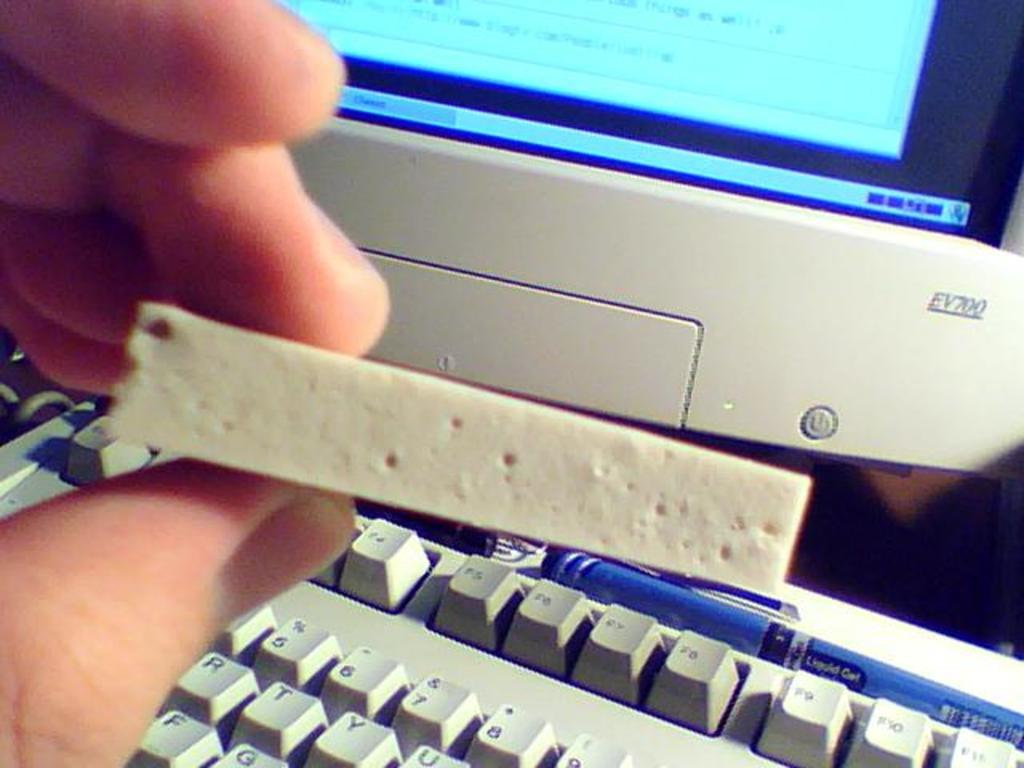<image>
Share a concise interpretation of the image provided. A person at a computer holding a sponge in front of an EV700 monitor. 